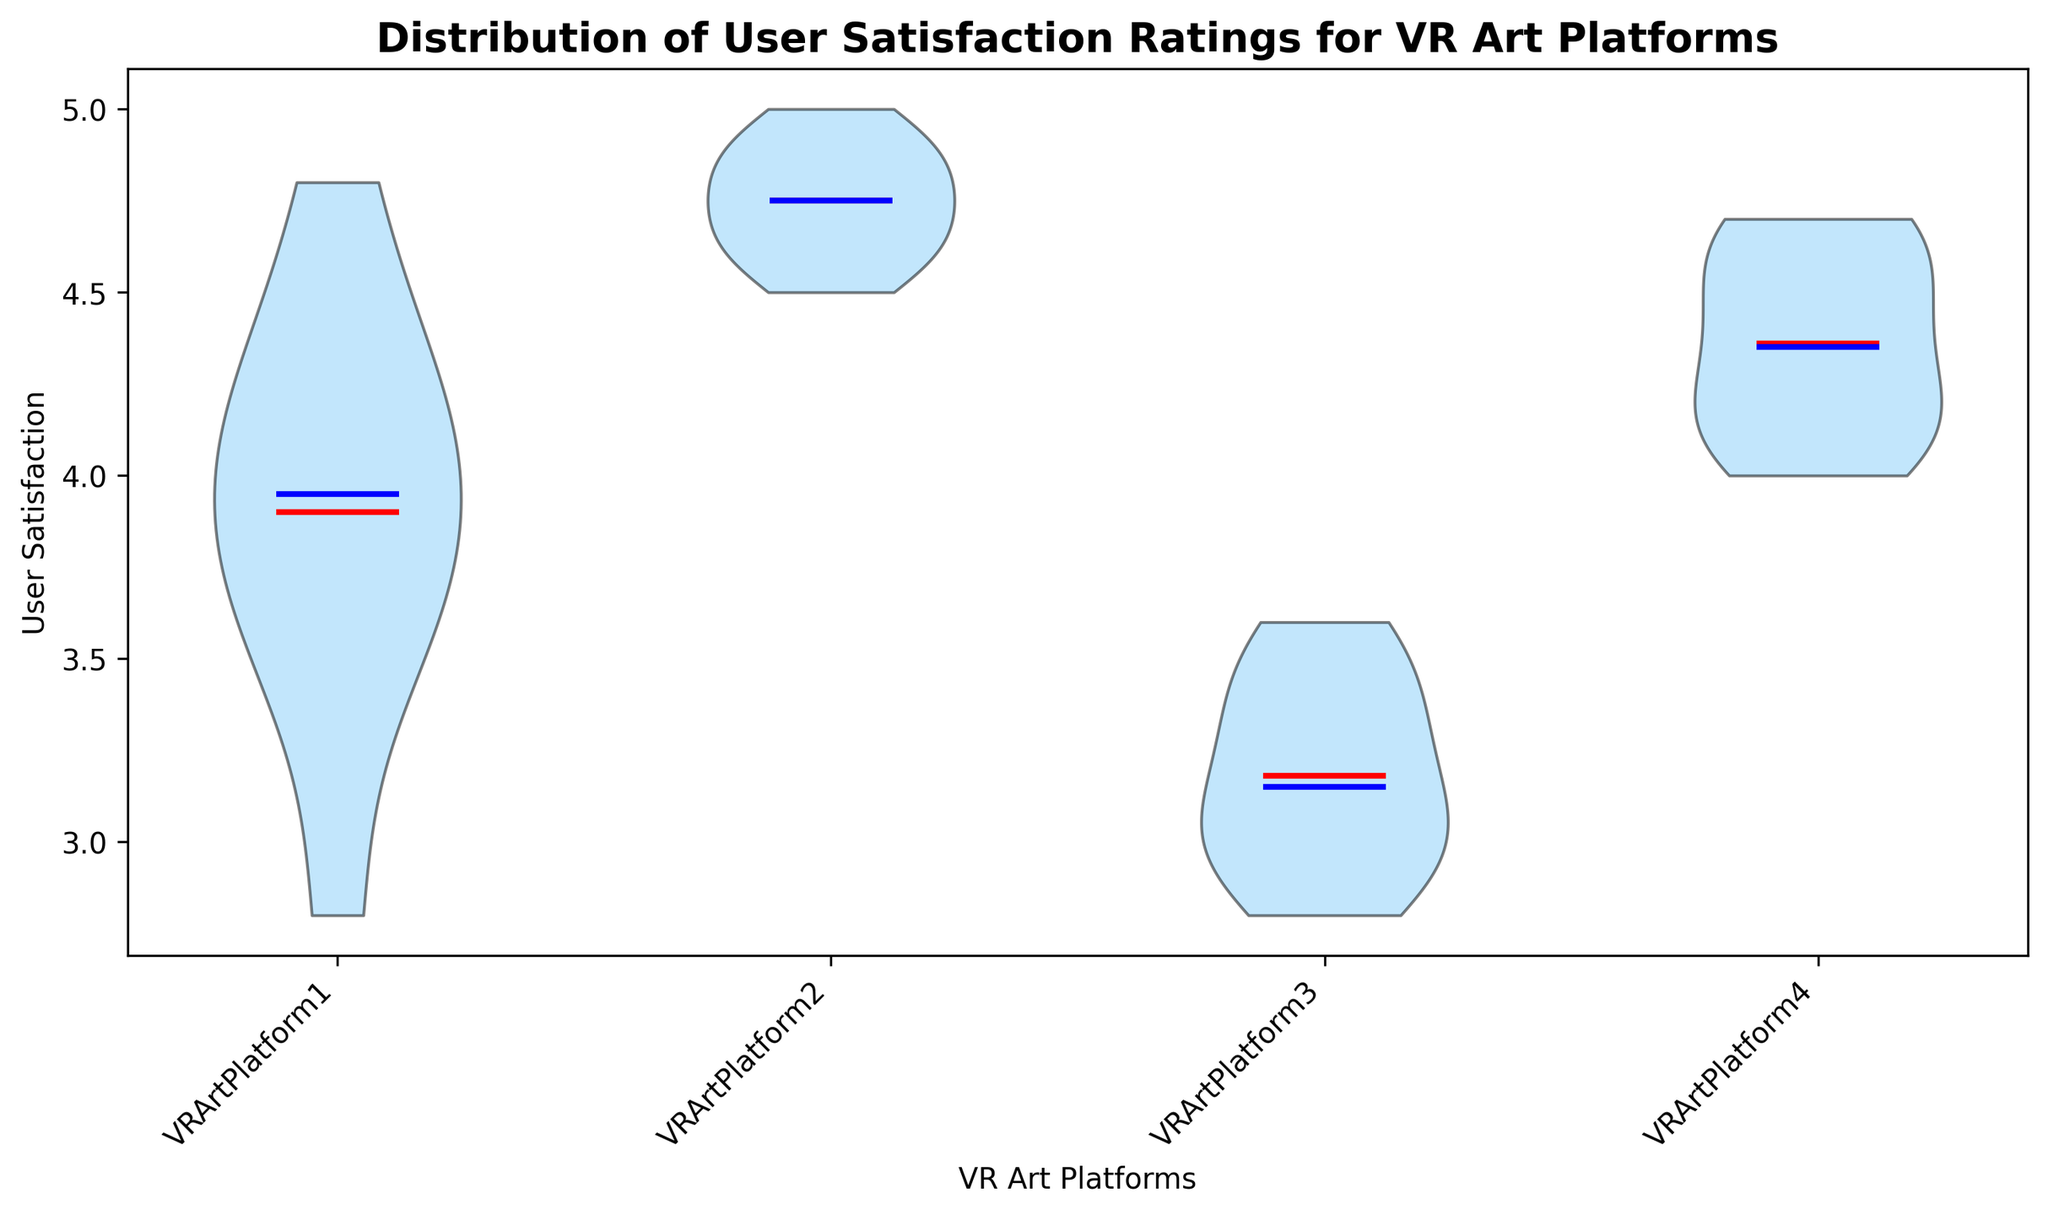Which VR art platform has the highest median user satisfaction rating? The blue line in each plot represents the median user satisfaction rating. VRArtPlatform2 has the highest median rating since its blue median line is positioned higher than those of the other platforms.
Answer: VRArtPlatform2 Which platform shows the greatest variation in user satisfaction ratings? The width of the body of the violin plot indicates the density of the data points. VRArtPlatform1 shows the greatest variation as it has the widest range on the y-axis.
Answer: VRArtPlatform1 What is the mean user satisfaction rating for VRArtPlatform3? The red line and marker in each plot represent the mean user satisfaction rating. For VRArtPlatform3, the red line is positioned around 3.1.
Answer: 3.1 Which two platforms have the closest mean user satisfaction ratings? Comparing the positions of the red means lines, VRArtPlatform1 and VRArtPlatform4 have close mean ratings, both centered around 4.0 to 4.2.
Answer: VRArtPlatform1 and VRArtPlatform4 Which platform has the lowest median user satisfaction rating? The platform whose blue median line is positioned the lowest on the y-axis is VRArtPlatform3.
Answer: VRArtPlatform3 Is there any platform where the mean and median user satisfaction ratings are noticeably different? The positions of the red mean line and the blue median line in the plots need to be compared for each platform. VRArtPlatform1 shows a noticeable difference where the mean is lower than the median.
Answer: VRArtPlatform1 By how much does the median user satisfaction rating of VRArtPlatform2 exceed that of VRArtPlatform3? The median rating of VRArtPlatform2 is around 4.8, and for VRArtPlatform3, it is 3.0. Subtract 3.0 from 4.8 to get the difference.
Answer: 1.8 Compare the shapes of the distribution for VRArtPlatform4 and VRArtPlatform1. Which one shows a more symmetrical distribution? For a symmetrical distribution, the violin plot is evenly spread around the center line. VRArtPlatform4 is more symmetrical compared to VRArtPlatform1, which is skewed.
Answer: VRArtPlatform4 Which platform shows a possible presence of outliers in user satisfaction ratings? The presence of outliers is often indicated by points outside the violin body, but the figure does not show outliers explicitly. Thus, we infer possible outliers based on the spread. VRArtPlatform1 and VRArtPlatform3, as they have wider spreads close to the edges, likely have outliers.
Answer: VRArtPlatform1 and VRArtPlatform3 